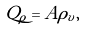Convert formula to latex. <formula><loc_0><loc_0><loc_500><loc_500>Q _ { \rho } = A { \rho } _ { v } ,</formula> 